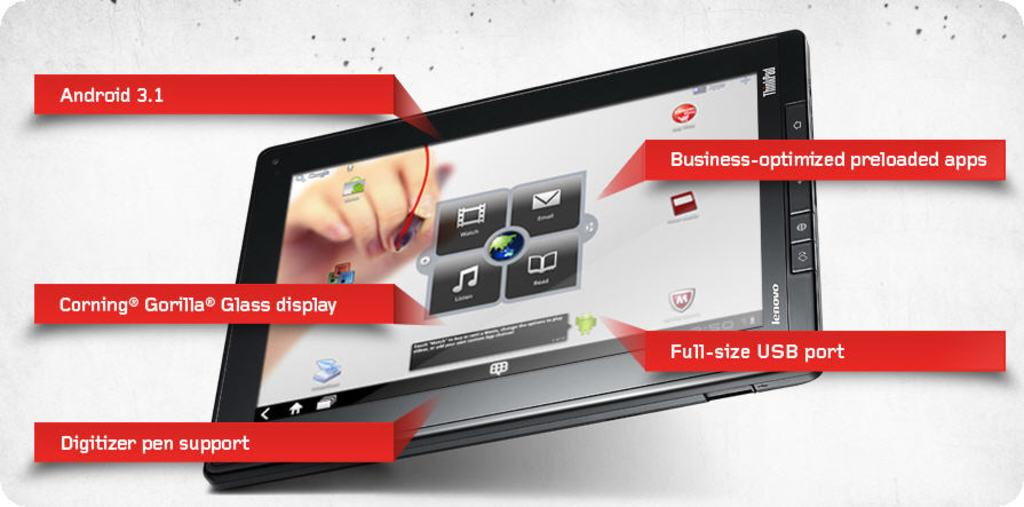<image>
Summarize the visual content of the image. a notepad with a full-size USB port prompt 